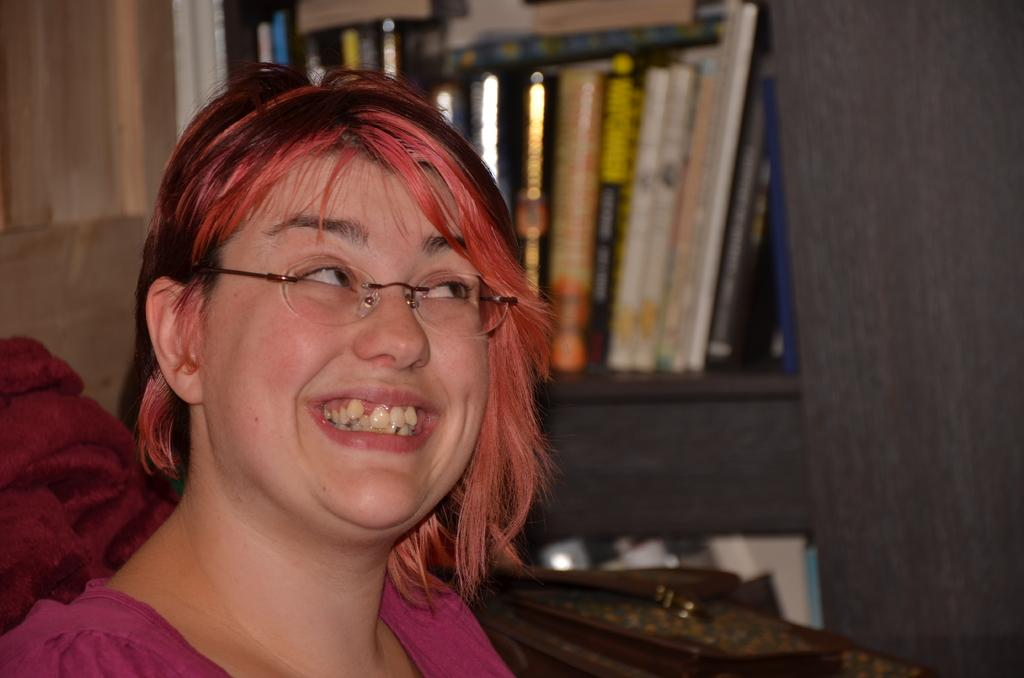Who is the main subject in the image? There is a woman in the image. What is the woman wearing in the image? The woman is wearing spectacles in the image. What can be seen behind the woman in the image? There are books and some objects visible behind the woman in the image. What type of food is the woman eating in the image? There is no food visible in the image, so it cannot be determined what the woman might be eating. 